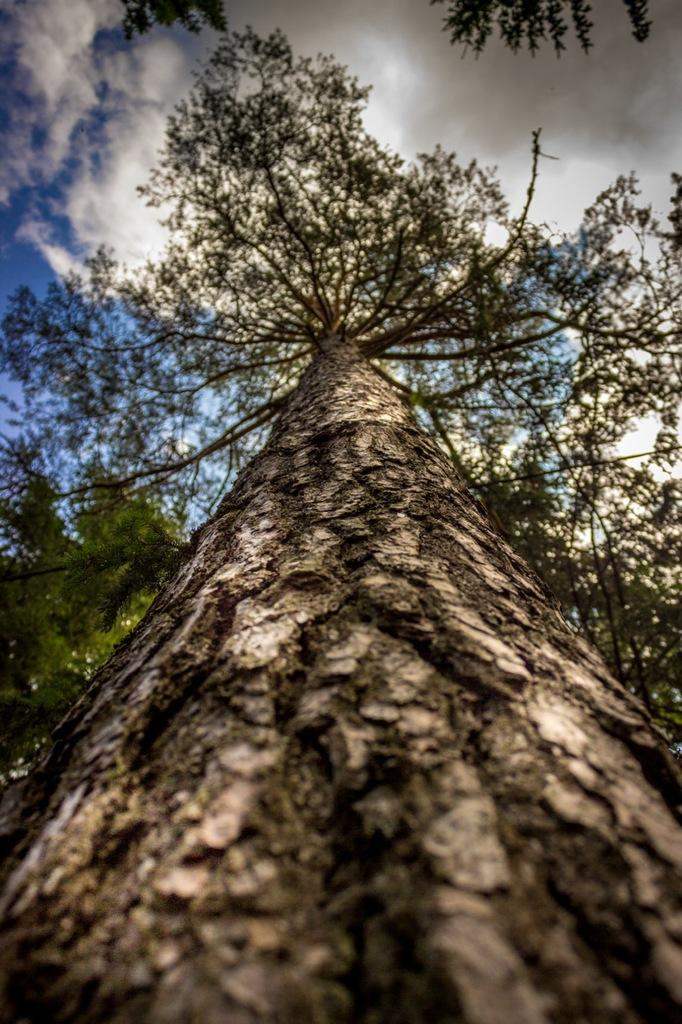What is the main subject in the center of the image? There is a tree in the center of the image. What can be seen in the sky at the top of the image? There are clouds visible at the top of the image. What else is visible in the sky at the top of the image? The sky is visible at the top of the image. Can you tell me how the manager is interacting with the tree in the image? There is no manager present in the image, so it is not possible to determine how they might interact with the tree. 